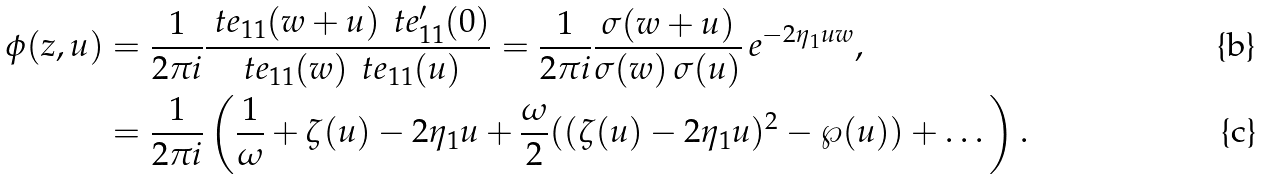<formula> <loc_0><loc_0><loc_500><loc_500>\phi ( z , u ) & = \frac { 1 } { 2 \pi i } \frac { \ t e _ { 1 1 } ( w + u ) \, \ t e ^ { \prime } _ { 1 1 } ( 0 ) } { \ t e _ { 1 1 } ( w ) \, \ t e _ { 1 1 } ( u ) } = \frac { 1 } { 2 \pi i } \frac { \sigma ( w + u ) } { \sigma ( w ) \, \sigma ( u ) } \, e ^ { - 2 \eta _ { 1 } u w } , \\ & = \frac { 1 } { 2 \pi i } \left ( \frac { 1 } { \omega } + \zeta ( u ) - 2 \eta _ { 1 } u + \frac { \omega } { 2 } ( ( \zeta ( u ) - 2 \eta _ { 1 } u ) ^ { 2 } - \wp ( u ) ) + \dots \right ) .</formula> 